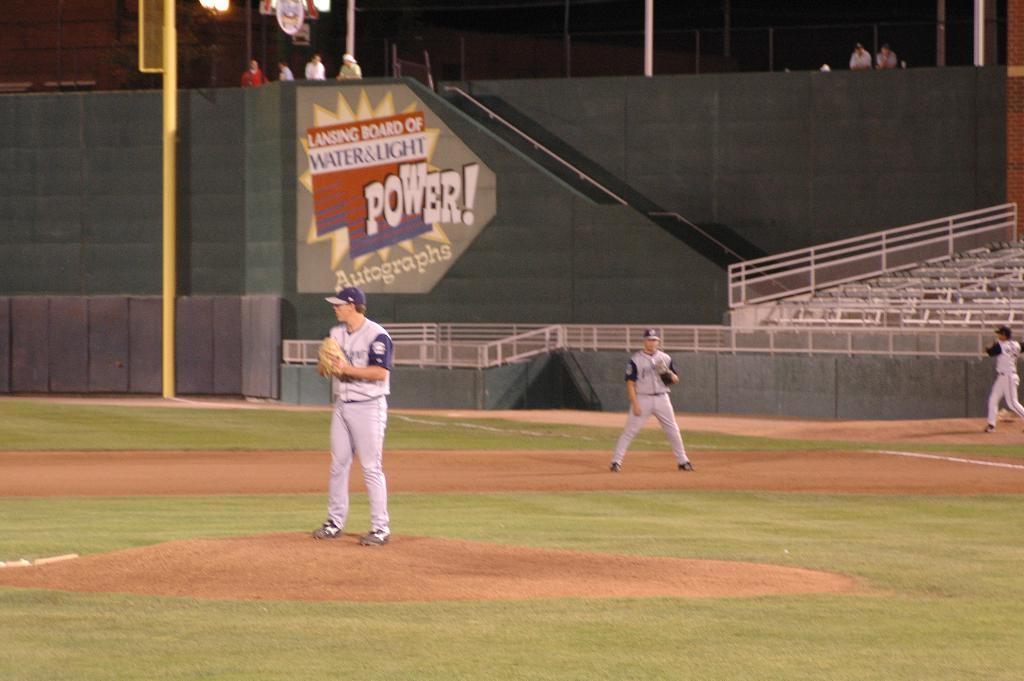<image>
Write a terse but informative summary of the picture. The stadium for the baseball players have a sponsor of the Lancing Board of water and light. 